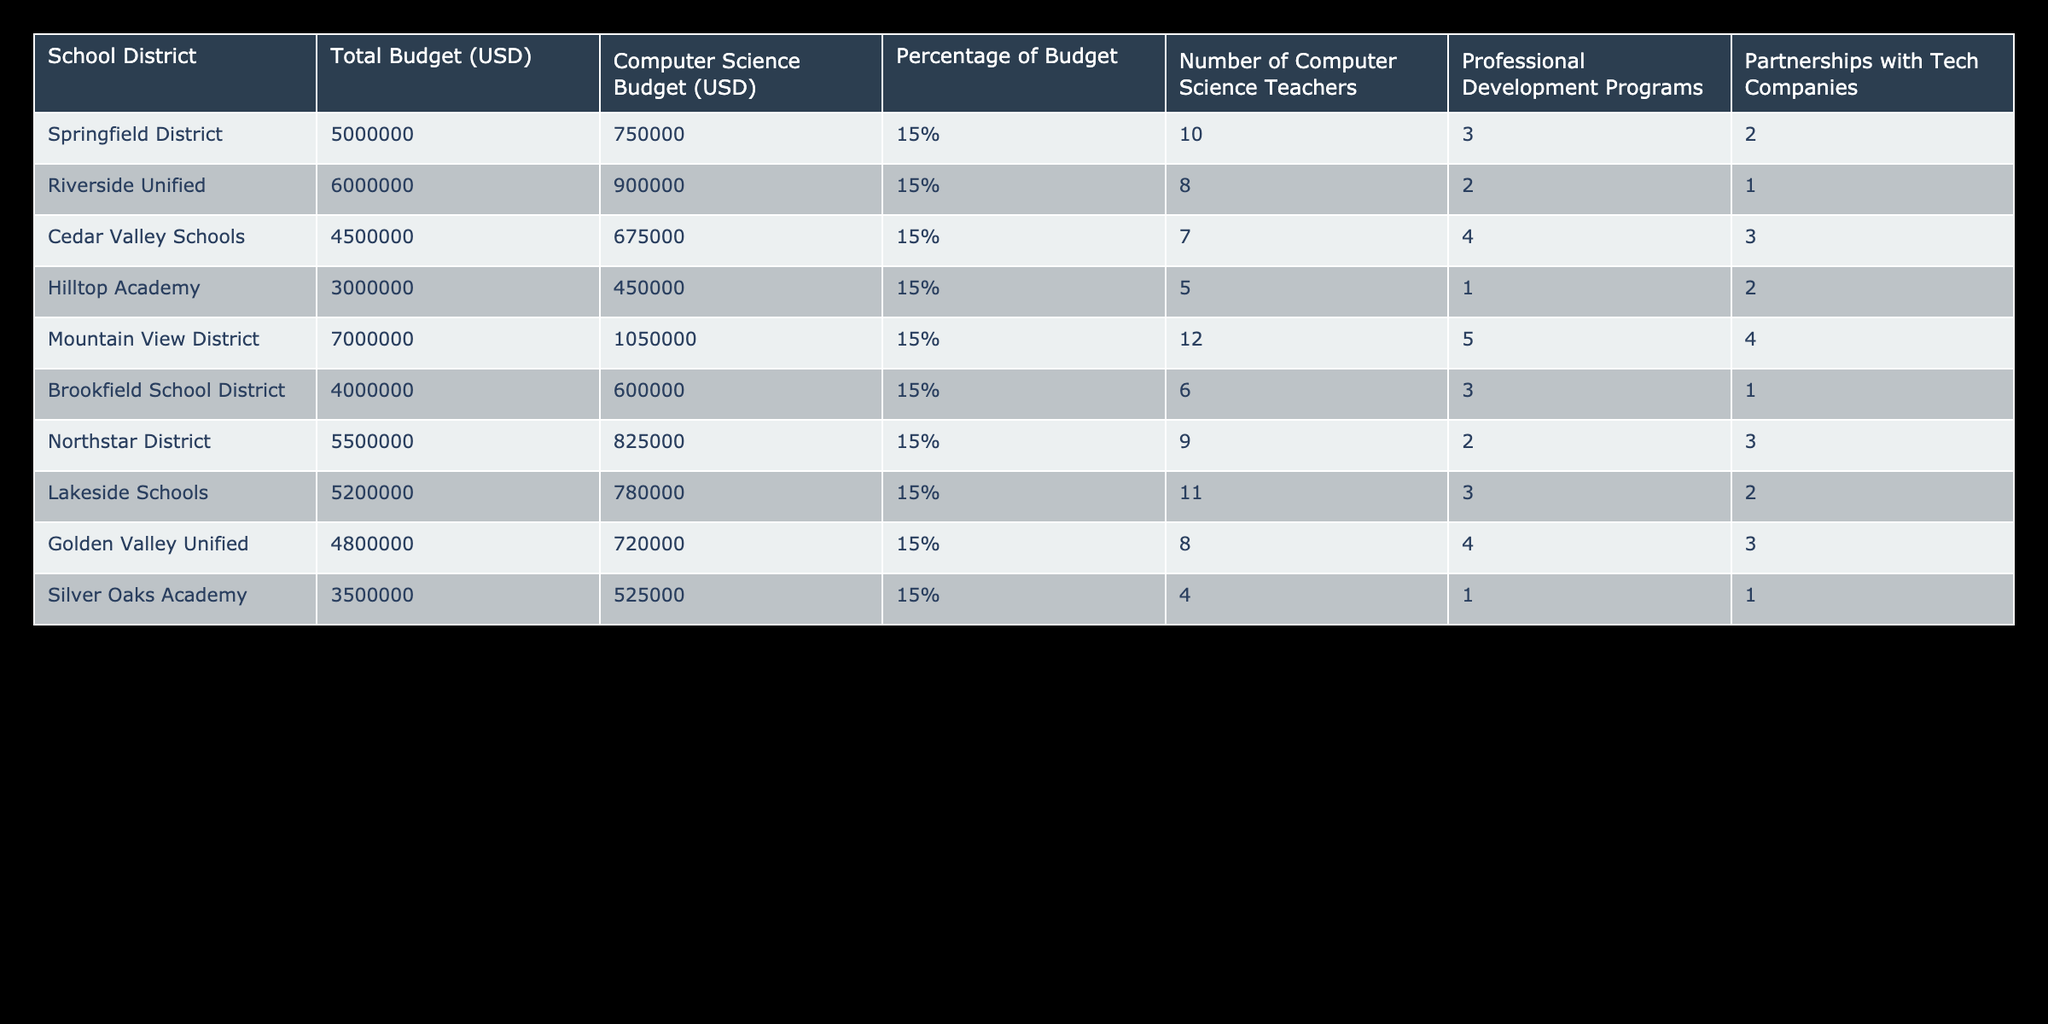What is the total budget for Springfield District? The total budget for Springfield District is directly listed in the table under the "Total Budget (USD)" column. It shows as 5000000.
Answer: 5000000 What percentage of the total budget does Cedar Valley Schools allocate for Computer Science? Cedar Valley Schools allocates a percentage of 15% for Computer Science, as indicated in the "Percentage of Budget" column.
Answer: 15% How many Computer Science teachers does Mountain View District have? The number of Computer Science teachers for Mountain View District can be found in the "Number of Computer Science Teachers" column, which states there are 12 teachers.
Answer: 12 What is the average Computer Science budget across all districts? To find the average Computer Science budget, add all Computer Science budgets: 750000 + 900000 + 675000 + 450000 + 1050000 + 600000 + 825000 + 780000 + 720000 + 525000 = 7350000. Then divide by the number of districts (10), which gives 7350000 / 10 = 735000.
Answer: 735000 Does Northstar District have more partnerships with tech companies than Silver Oaks Academy? Northstar District has 3 partnerships while Silver Oaks Academy has only 1. Thus, Northstar District does have more partnerships.
Answer: Yes Which district has the highest number of professional development programs? By reviewing the "Professional Development Programs" column, Mountain View District shows the highest number with 5 programs.
Answer: Mountain View District What is the total number of Computer Science teachers in all districts combined? To find the total, sum the number of teachers: 10 + 8 + 7 + 5 + 12 + 6 + 9 + 11 + 8 + 4 = 70. Thus, the total number of Computer Science teachers is 70.
Answer: 70 Is it true that Riverside Unified has a Computer Science budget higher than the average Computer Science budget? No, the average Computer Science budget is 735000, and Riverside Unified has a budget of 900000, which is higher. Thereby, the statement is true.
Answer: True How many districts have 5 or more professional development programs? The table shows 4 districts with 5 or more programs: Mountain View District (5), Cedar Valley Schools (4), and no others. Thus, the answer is 1.
Answer: 1 